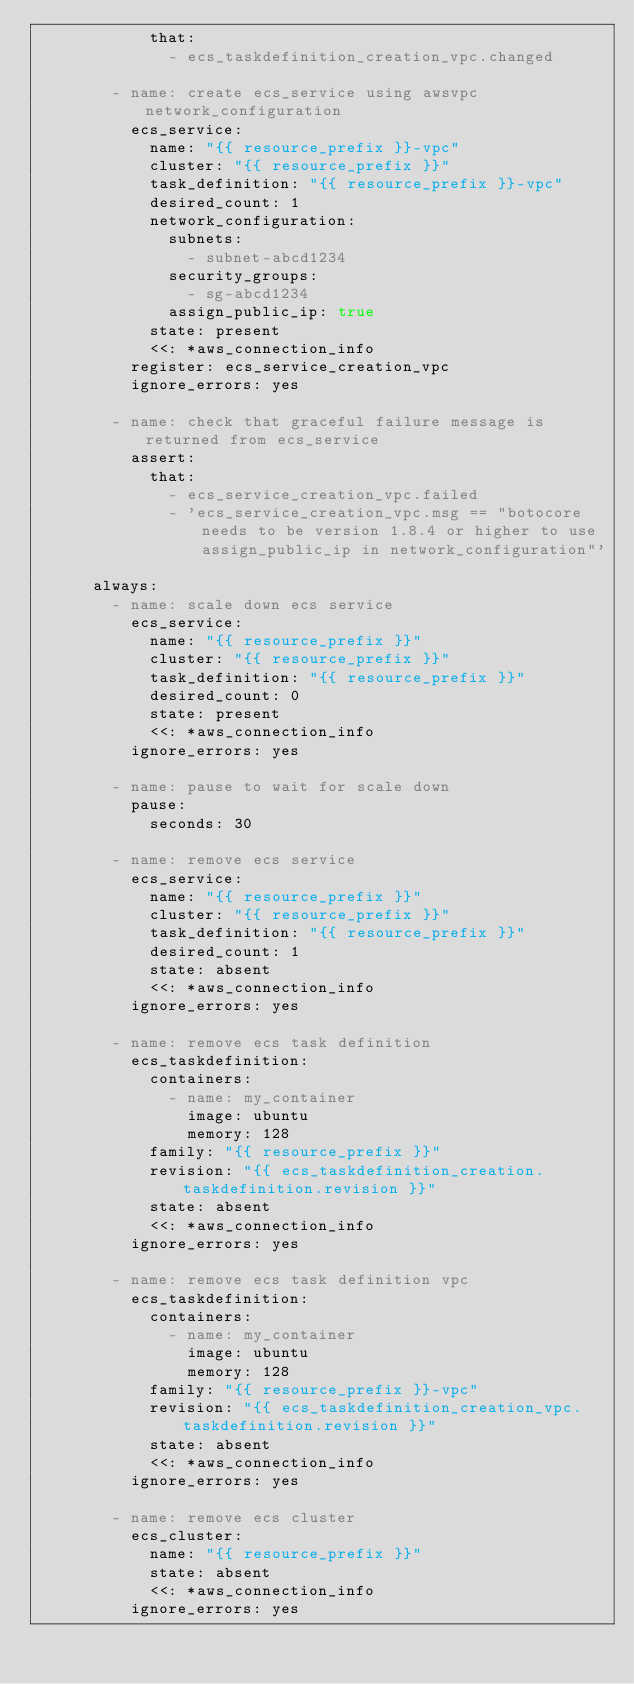Convert code to text. <code><loc_0><loc_0><loc_500><loc_500><_YAML_>            that:
              - ecs_taskdefinition_creation_vpc.changed

        - name: create ecs_service using awsvpc network_configuration
          ecs_service:
            name: "{{ resource_prefix }}-vpc"
            cluster: "{{ resource_prefix }}"
            task_definition: "{{ resource_prefix }}-vpc"
            desired_count: 1
            network_configuration:
              subnets:
                - subnet-abcd1234
              security_groups:
                - sg-abcd1234
              assign_public_ip: true
            state: present
            <<: *aws_connection_info
          register: ecs_service_creation_vpc
          ignore_errors: yes

        - name: check that graceful failure message is returned from ecs_service
          assert:
            that:
              - ecs_service_creation_vpc.failed
              - 'ecs_service_creation_vpc.msg == "botocore needs to be version 1.8.4 or higher to use assign_public_ip in network_configuration"'

      always:
        - name: scale down ecs service
          ecs_service:
            name: "{{ resource_prefix }}"
            cluster: "{{ resource_prefix }}"
            task_definition: "{{ resource_prefix }}"
            desired_count: 0
            state: present
            <<: *aws_connection_info
          ignore_errors: yes

        - name: pause to wait for scale down
          pause:
            seconds: 30

        - name: remove ecs service
          ecs_service:
            name: "{{ resource_prefix }}"
            cluster: "{{ resource_prefix }}"
            task_definition: "{{ resource_prefix }}"
            desired_count: 1
            state: absent
            <<: *aws_connection_info
          ignore_errors: yes

        - name: remove ecs task definition
          ecs_taskdefinition:
            containers:
              - name: my_container
                image: ubuntu
                memory: 128
            family: "{{ resource_prefix }}"
            revision: "{{ ecs_taskdefinition_creation.taskdefinition.revision }}"
            state: absent
            <<: *aws_connection_info
          ignore_errors: yes

        - name: remove ecs task definition vpc
          ecs_taskdefinition:
            containers:
              - name: my_container
                image: ubuntu
                memory: 128
            family: "{{ resource_prefix }}-vpc"
            revision: "{{ ecs_taskdefinition_creation_vpc.taskdefinition.revision }}"
            state: absent
            <<: *aws_connection_info
          ignore_errors: yes

        - name: remove ecs cluster
          ecs_cluster:
            name: "{{ resource_prefix }}"
            state: absent
            <<: *aws_connection_info
          ignore_errors: yes
</code> 